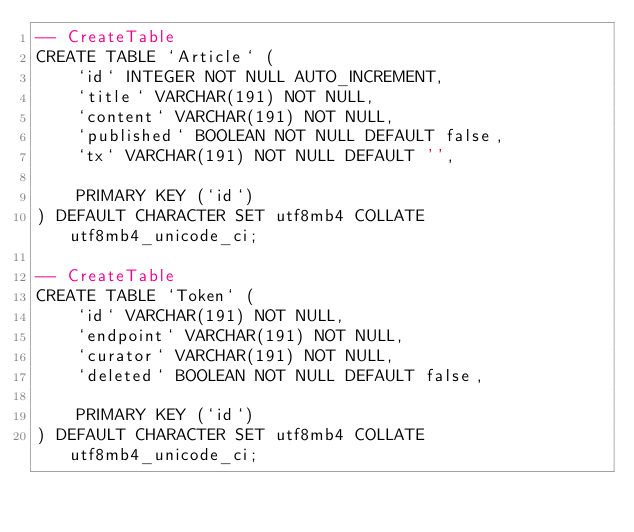<code> <loc_0><loc_0><loc_500><loc_500><_SQL_>-- CreateTable
CREATE TABLE `Article` (
    `id` INTEGER NOT NULL AUTO_INCREMENT,
    `title` VARCHAR(191) NOT NULL,
    `content` VARCHAR(191) NOT NULL,
    `published` BOOLEAN NOT NULL DEFAULT false,
    `tx` VARCHAR(191) NOT NULL DEFAULT '',

    PRIMARY KEY (`id`)
) DEFAULT CHARACTER SET utf8mb4 COLLATE utf8mb4_unicode_ci;

-- CreateTable
CREATE TABLE `Token` (
    `id` VARCHAR(191) NOT NULL,
    `endpoint` VARCHAR(191) NOT NULL,
    `curator` VARCHAR(191) NOT NULL,
    `deleted` BOOLEAN NOT NULL DEFAULT false,

    PRIMARY KEY (`id`)
) DEFAULT CHARACTER SET utf8mb4 COLLATE utf8mb4_unicode_ci;
</code> 